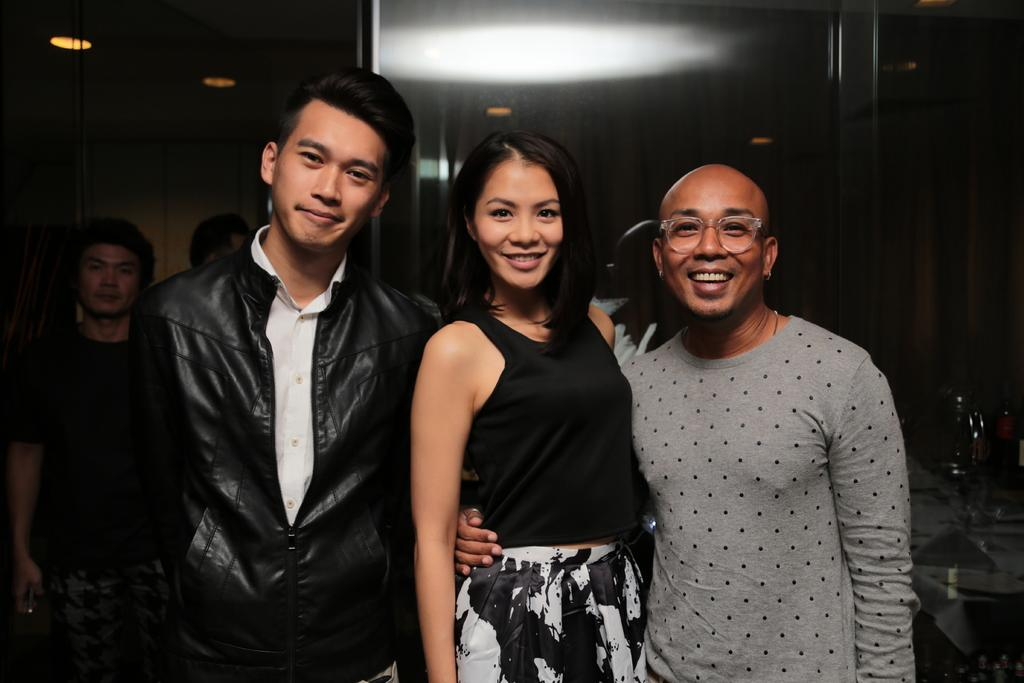How many people are present in the image? There are three people in the image. What are the three people doing in the image? The three people are giving stills and smiling. Are there any other people visible in the image? Yes, there are two people in the background of the image. What type of silk is being used by the animal in the image? There is no animal or silk present in the image. How does the connection between the three people affect the image? There is no mention of a connection between the three people in the image. 